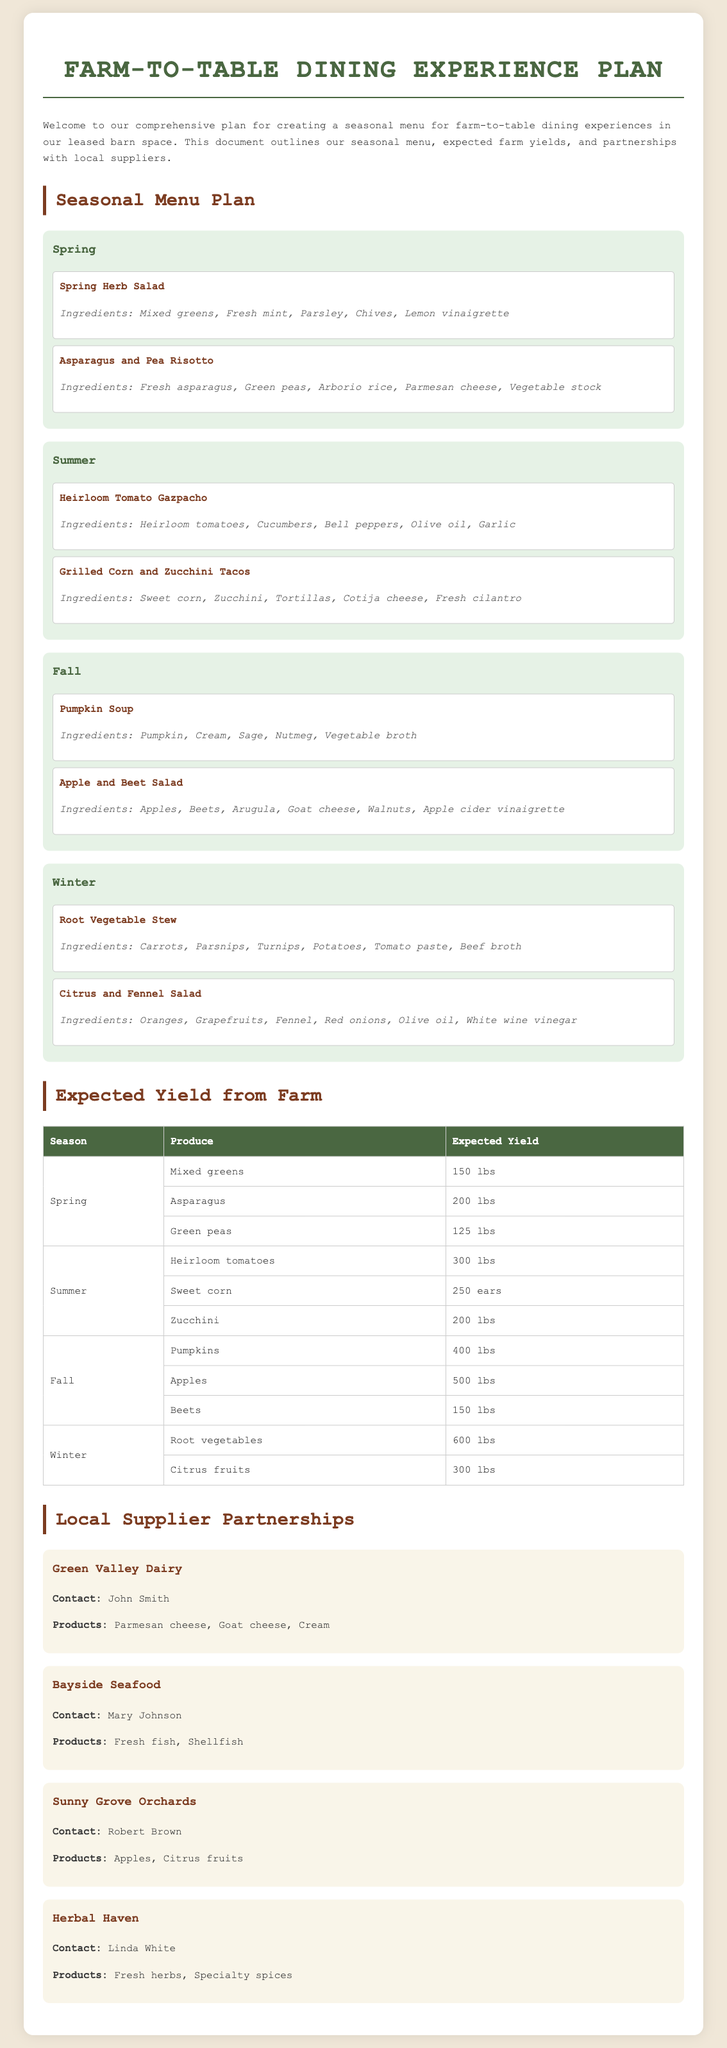What is the name of the dining experience? The document outlines the "Farm-to-Table Dining Experience Plan."
Answer: Farm-to-Table Dining Experience Plan How many pounds of green peas are expected in Spring? The expected yield table indicates that 125 lbs of green peas are expected in Spring.
Answer: 125 lbs What salad is featured in Winter? The document lists "Citrus and Fennel Salad" as a dish in the Winter section.
Answer: Citrus and Fennel Salad Who is the contact at Green Valley Dairy? The supplier section lists John Smith as the contact for Green Valley Dairy.
Answer: John Smith What type of cheese does Herbal Haven provide? According to the supplier information, Herbal Haven provides fresh herbs and specialty spices; cheese is not mentioned.
Answer: Fresh herbs, specialty spices What are the total expected yields for Fall? The yields for Fall consist of 400 lbs of pumpkins, 500 lbs of apples, and 150 lbs of beets, which totals 1050 lbs.
Answer: 1050 lbs Which produce has the highest expected yield in Winter? The table shows that root vegetables have the highest expected yield in Winter at 600 lbs.
Answer: Root vegetables What products does Bayside Seafood offer? The document specifies that Bayside Seafood offers fresh fish and shellfish.
Answer: Fresh fish, shellfish In which season is Asparagus harvested? The seasonal menu clearly states that asparagus is harvested in Spring.
Answer: Spring 